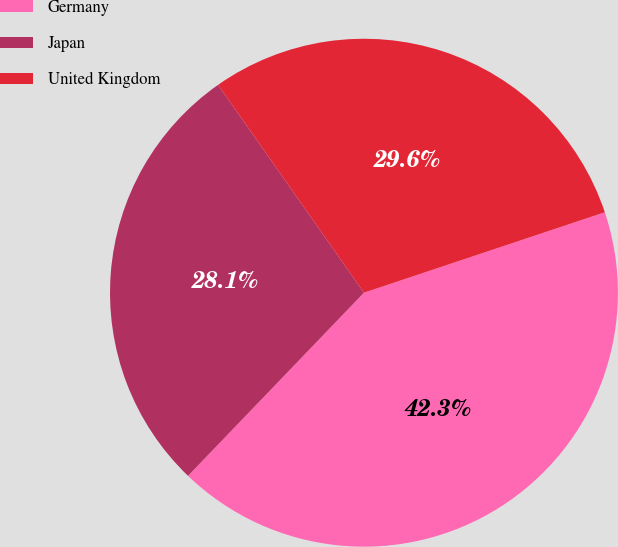<chart> <loc_0><loc_0><loc_500><loc_500><pie_chart><fcel>Germany<fcel>Japan<fcel>United Kingdom<nl><fcel>42.31%<fcel>28.08%<fcel>29.61%<nl></chart> 